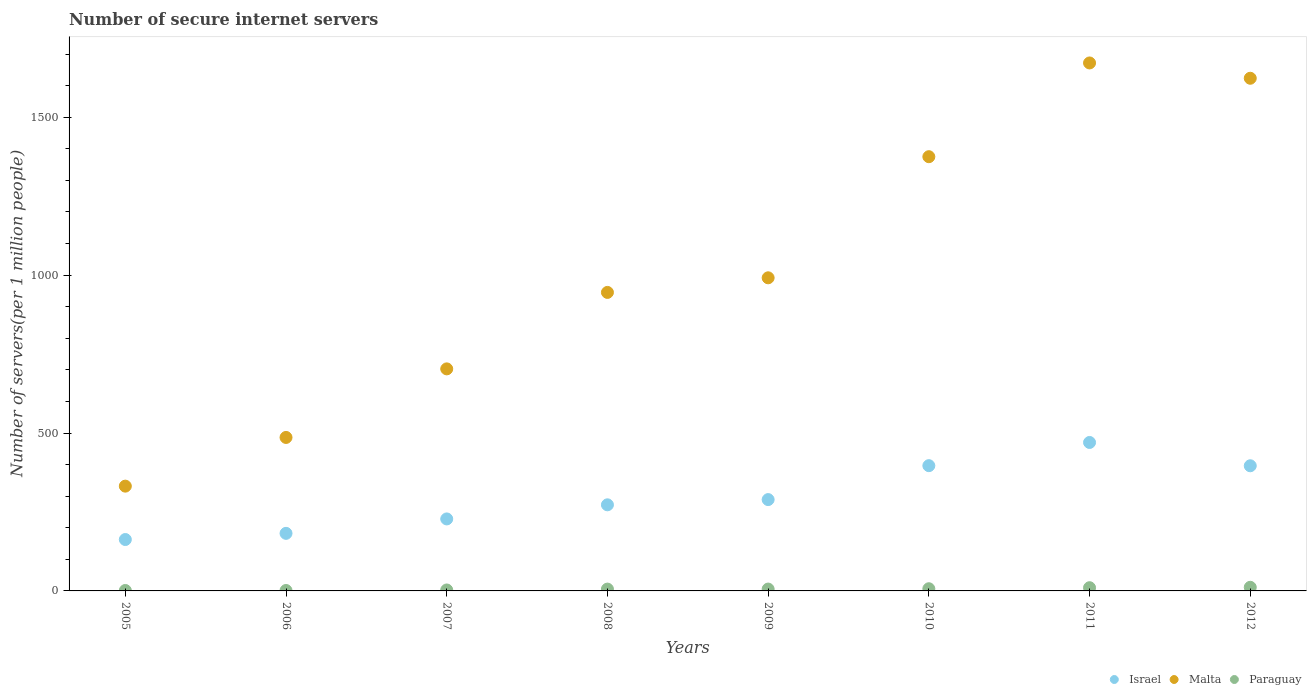What is the number of secure internet servers in Paraguay in 2006?
Your response must be concise. 1.36. Across all years, what is the maximum number of secure internet servers in Malta?
Provide a short and direct response. 1672. Across all years, what is the minimum number of secure internet servers in Malta?
Your answer should be compact. 331.82. In which year was the number of secure internet servers in Israel maximum?
Keep it short and to the point. 2011. In which year was the number of secure internet servers in Paraguay minimum?
Your answer should be compact. 2006. What is the total number of secure internet servers in Malta in the graph?
Provide a succinct answer. 8128.61. What is the difference between the number of secure internet servers in Israel in 2009 and that in 2010?
Give a very brief answer. -107.44. What is the difference between the number of secure internet servers in Paraguay in 2011 and the number of secure internet servers in Malta in 2008?
Make the answer very short. -935.17. What is the average number of secure internet servers in Paraguay per year?
Ensure brevity in your answer.  5.74. In the year 2007, what is the difference between the number of secure internet servers in Israel and number of secure internet servers in Paraguay?
Your response must be concise. 224.97. What is the ratio of the number of secure internet servers in Malta in 2010 to that in 2011?
Your response must be concise. 0.82. Is the difference between the number of secure internet servers in Israel in 2005 and 2006 greater than the difference between the number of secure internet servers in Paraguay in 2005 and 2006?
Offer a terse response. No. What is the difference between the highest and the second highest number of secure internet servers in Israel?
Ensure brevity in your answer.  73.48. What is the difference between the highest and the lowest number of secure internet servers in Paraguay?
Offer a very short reply. 10.08. Is it the case that in every year, the sum of the number of secure internet servers in Paraguay and number of secure internet servers in Israel  is greater than the number of secure internet servers in Malta?
Offer a terse response. No. Are the values on the major ticks of Y-axis written in scientific E-notation?
Provide a succinct answer. No. Does the graph contain grids?
Offer a terse response. No. Where does the legend appear in the graph?
Keep it short and to the point. Bottom right. How many legend labels are there?
Keep it short and to the point. 3. What is the title of the graph?
Your response must be concise. Number of secure internet servers. Does "East Asia (developing only)" appear as one of the legend labels in the graph?
Your answer should be compact. No. What is the label or title of the X-axis?
Make the answer very short. Years. What is the label or title of the Y-axis?
Your answer should be very brief. Number of servers(per 1 million people). What is the Number of servers(per 1 million people) in Israel in 2005?
Offer a very short reply. 162.77. What is the Number of servers(per 1 million people) in Malta in 2005?
Your answer should be very brief. 331.82. What is the Number of servers(per 1 million people) in Paraguay in 2005?
Your answer should be very brief. 1.38. What is the Number of servers(per 1 million people) of Israel in 2006?
Your answer should be very brief. 182.32. What is the Number of servers(per 1 million people) of Malta in 2006?
Ensure brevity in your answer.  486.05. What is the Number of servers(per 1 million people) of Paraguay in 2006?
Your response must be concise. 1.36. What is the Number of servers(per 1 million people) of Israel in 2007?
Your answer should be very brief. 227.99. What is the Number of servers(per 1 million people) in Malta in 2007?
Offer a very short reply. 703.18. What is the Number of servers(per 1 million people) of Paraguay in 2007?
Give a very brief answer. 3.02. What is the Number of servers(per 1 million people) of Israel in 2008?
Your answer should be very brief. 272.68. What is the Number of servers(per 1 million people) in Malta in 2008?
Give a very brief answer. 945.33. What is the Number of servers(per 1 million people) in Paraguay in 2008?
Provide a succinct answer. 5.79. What is the Number of servers(per 1 million people) in Israel in 2009?
Make the answer very short. 289.22. What is the Number of servers(per 1 million people) in Malta in 2009?
Provide a short and direct response. 991.57. What is the Number of servers(per 1 million people) of Paraguay in 2009?
Make the answer very short. 5.87. What is the Number of servers(per 1 million people) in Israel in 2010?
Provide a short and direct response. 396.66. What is the Number of servers(per 1 million people) in Malta in 2010?
Give a very brief answer. 1375.12. What is the Number of servers(per 1 million people) of Paraguay in 2010?
Provide a succinct answer. 6.92. What is the Number of servers(per 1 million people) of Israel in 2011?
Ensure brevity in your answer.  470.14. What is the Number of servers(per 1 million people) in Malta in 2011?
Provide a short and direct response. 1672. What is the Number of servers(per 1 million people) in Paraguay in 2011?
Ensure brevity in your answer.  10.17. What is the Number of servers(per 1 million people) of Israel in 2012?
Offer a very short reply. 396.31. What is the Number of servers(per 1 million people) in Malta in 2012?
Provide a succinct answer. 1623.54. What is the Number of servers(per 1 million people) of Paraguay in 2012?
Provide a short and direct response. 11.44. Across all years, what is the maximum Number of servers(per 1 million people) of Israel?
Give a very brief answer. 470.14. Across all years, what is the maximum Number of servers(per 1 million people) in Malta?
Offer a very short reply. 1672. Across all years, what is the maximum Number of servers(per 1 million people) of Paraguay?
Ensure brevity in your answer.  11.44. Across all years, what is the minimum Number of servers(per 1 million people) in Israel?
Make the answer very short. 162.77. Across all years, what is the minimum Number of servers(per 1 million people) in Malta?
Make the answer very short. 331.82. Across all years, what is the minimum Number of servers(per 1 million people) of Paraguay?
Your answer should be very brief. 1.36. What is the total Number of servers(per 1 million people) in Israel in the graph?
Ensure brevity in your answer.  2398.09. What is the total Number of servers(per 1 million people) in Malta in the graph?
Provide a succinct answer. 8128.61. What is the total Number of servers(per 1 million people) in Paraguay in the graph?
Offer a very short reply. 45.96. What is the difference between the Number of servers(per 1 million people) in Israel in 2005 and that in 2006?
Your answer should be compact. -19.55. What is the difference between the Number of servers(per 1 million people) of Malta in 2005 and that in 2006?
Give a very brief answer. -154.23. What is the difference between the Number of servers(per 1 million people) in Paraguay in 2005 and that in 2006?
Your answer should be very brief. 0.02. What is the difference between the Number of servers(per 1 million people) of Israel in 2005 and that in 2007?
Your answer should be compact. -65.22. What is the difference between the Number of servers(per 1 million people) of Malta in 2005 and that in 2007?
Provide a succinct answer. -371.36. What is the difference between the Number of servers(per 1 million people) of Paraguay in 2005 and that in 2007?
Ensure brevity in your answer.  -1.64. What is the difference between the Number of servers(per 1 million people) in Israel in 2005 and that in 2008?
Provide a succinct answer. -109.92. What is the difference between the Number of servers(per 1 million people) in Malta in 2005 and that in 2008?
Your answer should be very brief. -613.51. What is the difference between the Number of servers(per 1 million people) in Paraguay in 2005 and that in 2008?
Your answer should be very brief. -4.41. What is the difference between the Number of servers(per 1 million people) in Israel in 2005 and that in 2009?
Keep it short and to the point. -126.45. What is the difference between the Number of servers(per 1 million people) of Malta in 2005 and that in 2009?
Your answer should be very brief. -659.75. What is the difference between the Number of servers(per 1 million people) of Paraguay in 2005 and that in 2009?
Keep it short and to the point. -4.49. What is the difference between the Number of servers(per 1 million people) in Israel in 2005 and that in 2010?
Ensure brevity in your answer.  -233.89. What is the difference between the Number of servers(per 1 million people) of Malta in 2005 and that in 2010?
Your response must be concise. -1043.3. What is the difference between the Number of servers(per 1 million people) in Paraguay in 2005 and that in 2010?
Your response must be concise. -5.54. What is the difference between the Number of servers(per 1 million people) of Israel in 2005 and that in 2011?
Provide a short and direct response. -307.37. What is the difference between the Number of servers(per 1 million people) in Malta in 2005 and that in 2011?
Give a very brief answer. -1340.18. What is the difference between the Number of servers(per 1 million people) of Paraguay in 2005 and that in 2011?
Provide a succinct answer. -8.79. What is the difference between the Number of servers(per 1 million people) of Israel in 2005 and that in 2012?
Provide a short and direct response. -233.54. What is the difference between the Number of servers(per 1 million people) in Malta in 2005 and that in 2012?
Ensure brevity in your answer.  -1291.72. What is the difference between the Number of servers(per 1 million people) of Paraguay in 2005 and that in 2012?
Offer a terse response. -10.06. What is the difference between the Number of servers(per 1 million people) of Israel in 2006 and that in 2007?
Your answer should be very brief. -45.68. What is the difference between the Number of servers(per 1 million people) of Malta in 2006 and that in 2007?
Make the answer very short. -217.13. What is the difference between the Number of servers(per 1 million people) of Paraguay in 2006 and that in 2007?
Offer a terse response. -1.66. What is the difference between the Number of servers(per 1 million people) in Israel in 2006 and that in 2008?
Offer a very short reply. -90.37. What is the difference between the Number of servers(per 1 million people) of Malta in 2006 and that in 2008?
Your answer should be very brief. -459.28. What is the difference between the Number of servers(per 1 million people) in Paraguay in 2006 and that in 2008?
Make the answer very short. -4.43. What is the difference between the Number of servers(per 1 million people) in Israel in 2006 and that in 2009?
Make the answer very short. -106.91. What is the difference between the Number of servers(per 1 million people) in Malta in 2006 and that in 2009?
Make the answer very short. -505.52. What is the difference between the Number of servers(per 1 million people) in Paraguay in 2006 and that in 2009?
Give a very brief answer. -4.51. What is the difference between the Number of servers(per 1 million people) in Israel in 2006 and that in 2010?
Offer a terse response. -214.35. What is the difference between the Number of servers(per 1 million people) of Malta in 2006 and that in 2010?
Your answer should be compact. -889.07. What is the difference between the Number of servers(per 1 million people) in Paraguay in 2006 and that in 2010?
Offer a terse response. -5.56. What is the difference between the Number of servers(per 1 million people) of Israel in 2006 and that in 2011?
Make the answer very short. -287.82. What is the difference between the Number of servers(per 1 million people) of Malta in 2006 and that in 2011?
Ensure brevity in your answer.  -1185.95. What is the difference between the Number of servers(per 1 million people) in Paraguay in 2006 and that in 2011?
Make the answer very short. -8.81. What is the difference between the Number of servers(per 1 million people) in Israel in 2006 and that in 2012?
Ensure brevity in your answer.  -213.99. What is the difference between the Number of servers(per 1 million people) of Malta in 2006 and that in 2012?
Offer a very short reply. -1137.49. What is the difference between the Number of servers(per 1 million people) in Paraguay in 2006 and that in 2012?
Ensure brevity in your answer.  -10.08. What is the difference between the Number of servers(per 1 million people) of Israel in 2007 and that in 2008?
Offer a terse response. -44.69. What is the difference between the Number of servers(per 1 million people) in Malta in 2007 and that in 2008?
Keep it short and to the point. -242.15. What is the difference between the Number of servers(per 1 million people) of Paraguay in 2007 and that in 2008?
Offer a very short reply. -2.77. What is the difference between the Number of servers(per 1 million people) of Israel in 2007 and that in 2009?
Keep it short and to the point. -61.23. What is the difference between the Number of servers(per 1 million people) of Malta in 2007 and that in 2009?
Offer a very short reply. -288.39. What is the difference between the Number of servers(per 1 million people) in Paraguay in 2007 and that in 2009?
Provide a succinct answer. -2.86. What is the difference between the Number of servers(per 1 million people) in Israel in 2007 and that in 2010?
Offer a terse response. -168.67. What is the difference between the Number of servers(per 1 million people) of Malta in 2007 and that in 2010?
Offer a very short reply. -671.94. What is the difference between the Number of servers(per 1 million people) in Paraguay in 2007 and that in 2010?
Keep it short and to the point. -3.91. What is the difference between the Number of servers(per 1 million people) of Israel in 2007 and that in 2011?
Offer a very short reply. -242.15. What is the difference between the Number of servers(per 1 million people) of Malta in 2007 and that in 2011?
Your response must be concise. -968.82. What is the difference between the Number of servers(per 1 million people) of Paraguay in 2007 and that in 2011?
Offer a terse response. -7.15. What is the difference between the Number of servers(per 1 million people) in Israel in 2007 and that in 2012?
Your answer should be compact. -168.32. What is the difference between the Number of servers(per 1 million people) of Malta in 2007 and that in 2012?
Your response must be concise. -920.36. What is the difference between the Number of servers(per 1 million people) of Paraguay in 2007 and that in 2012?
Give a very brief answer. -8.43. What is the difference between the Number of servers(per 1 million people) in Israel in 2008 and that in 2009?
Your answer should be very brief. -16.54. What is the difference between the Number of servers(per 1 million people) in Malta in 2008 and that in 2009?
Provide a succinct answer. -46.24. What is the difference between the Number of servers(per 1 million people) in Paraguay in 2008 and that in 2009?
Give a very brief answer. -0.09. What is the difference between the Number of servers(per 1 million people) in Israel in 2008 and that in 2010?
Ensure brevity in your answer.  -123.98. What is the difference between the Number of servers(per 1 million people) of Malta in 2008 and that in 2010?
Keep it short and to the point. -429.79. What is the difference between the Number of servers(per 1 million people) of Paraguay in 2008 and that in 2010?
Provide a succinct answer. -1.14. What is the difference between the Number of servers(per 1 million people) of Israel in 2008 and that in 2011?
Your answer should be compact. -197.45. What is the difference between the Number of servers(per 1 million people) of Malta in 2008 and that in 2011?
Provide a succinct answer. -726.67. What is the difference between the Number of servers(per 1 million people) of Paraguay in 2008 and that in 2011?
Keep it short and to the point. -4.38. What is the difference between the Number of servers(per 1 million people) in Israel in 2008 and that in 2012?
Provide a succinct answer. -123.62. What is the difference between the Number of servers(per 1 million people) of Malta in 2008 and that in 2012?
Make the answer very short. -678.2. What is the difference between the Number of servers(per 1 million people) in Paraguay in 2008 and that in 2012?
Offer a very short reply. -5.66. What is the difference between the Number of servers(per 1 million people) in Israel in 2009 and that in 2010?
Offer a terse response. -107.44. What is the difference between the Number of servers(per 1 million people) in Malta in 2009 and that in 2010?
Offer a terse response. -383.55. What is the difference between the Number of servers(per 1 million people) in Paraguay in 2009 and that in 2010?
Offer a terse response. -1.05. What is the difference between the Number of servers(per 1 million people) in Israel in 2009 and that in 2011?
Provide a short and direct response. -180.92. What is the difference between the Number of servers(per 1 million people) in Malta in 2009 and that in 2011?
Your response must be concise. -680.43. What is the difference between the Number of servers(per 1 million people) of Paraguay in 2009 and that in 2011?
Provide a succinct answer. -4.29. What is the difference between the Number of servers(per 1 million people) in Israel in 2009 and that in 2012?
Your answer should be very brief. -107.09. What is the difference between the Number of servers(per 1 million people) in Malta in 2009 and that in 2012?
Offer a very short reply. -631.96. What is the difference between the Number of servers(per 1 million people) of Paraguay in 2009 and that in 2012?
Offer a very short reply. -5.57. What is the difference between the Number of servers(per 1 million people) in Israel in 2010 and that in 2011?
Your answer should be compact. -73.48. What is the difference between the Number of servers(per 1 million people) in Malta in 2010 and that in 2011?
Offer a terse response. -296.88. What is the difference between the Number of servers(per 1 million people) of Paraguay in 2010 and that in 2011?
Provide a succinct answer. -3.24. What is the difference between the Number of servers(per 1 million people) in Israel in 2010 and that in 2012?
Offer a terse response. 0.35. What is the difference between the Number of servers(per 1 million people) of Malta in 2010 and that in 2012?
Provide a succinct answer. -248.41. What is the difference between the Number of servers(per 1 million people) in Paraguay in 2010 and that in 2012?
Offer a terse response. -4.52. What is the difference between the Number of servers(per 1 million people) in Israel in 2011 and that in 2012?
Provide a succinct answer. 73.83. What is the difference between the Number of servers(per 1 million people) in Malta in 2011 and that in 2012?
Your response must be concise. 48.46. What is the difference between the Number of servers(per 1 million people) of Paraguay in 2011 and that in 2012?
Your answer should be compact. -1.27. What is the difference between the Number of servers(per 1 million people) of Israel in 2005 and the Number of servers(per 1 million people) of Malta in 2006?
Your response must be concise. -323.28. What is the difference between the Number of servers(per 1 million people) in Israel in 2005 and the Number of servers(per 1 million people) in Paraguay in 2006?
Provide a succinct answer. 161.41. What is the difference between the Number of servers(per 1 million people) in Malta in 2005 and the Number of servers(per 1 million people) in Paraguay in 2006?
Make the answer very short. 330.46. What is the difference between the Number of servers(per 1 million people) in Israel in 2005 and the Number of servers(per 1 million people) in Malta in 2007?
Give a very brief answer. -540.41. What is the difference between the Number of servers(per 1 million people) of Israel in 2005 and the Number of servers(per 1 million people) of Paraguay in 2007?
Your answer should be very brief. 159.75. What is the difference between the Number of servers(per 1 million people) of Malta in 2005 and the Number of servers(per 1 million people) of Paraguay in 2007?
Offer a terse response. 328.8. What is the difference between the Number of servers(per 1 million people) in Israel in 2005 and the Number of servers(per 1 million people) in Malta in 2008?
Provide a short and direct response. -782.57. What is the difference between the Number of servers(per 1 million people) of Israel in 2005 and the Number of servers(per 1 million people) of Paraguay in 2008?
Your answer should be very brief. 156.98. What is the difference between the Number of servers(per 1 million people) in Malta in 2005 and the Number of servers(per 1 million people) in Paraguay in 2008?
Your answer should be very brief. 326.03. What is the difference between the Number of servers(per 1 million people) in Israel in 2005 and the Number of servers(per 1 million people) in Malta in 2009?
Your answer should be compact. -828.8. What is the difference between the Number of servers(per 1 million people) in Israel in 2005 and the Number of servers(per 1 million people) in Paraguay in 2009?
Your response must be concise. 156.89. What is the difference between the Number of servers(per 1 million people) in Malta in 2005 and the Number of servers(per 1 million people) in Paraguay in 2009?
Ensure brevity in your answer.  325.94. What is the difference between the Number of servers(per 1 million people) in Israel in 2005 and the Number of servers(per 1 million people) in Malta in 2010?
Offer a very short reply. -1212.36. What is the difference between the Number of servers(per 1 million people) of Israel in 2005 and the Number of servers(per 1 million people) of Paraguay in 2010?
Ensure brevity in your answer.  155.84. What is the difference between the Number of servers(per 1 million people) in Malta in 2005 and the Number of servers(per 1 million people) in Paraguay in 2010?
Give a very brief answer. 324.9. What is the difference between the Number of servers(per 1 million people) of Israel in 2005 and the Number of servers(per 1 million people) of Malta in 2011?
Your response must be concise. -1509.23. What is the difference between the Number of servers(per 1 million people) in Israel in 2005 and the Number of servers(per 1 million people) in Paraguay in 2011?
Your answer should be very brief. 152.6. What is the difference between the Number of servers(per 1 million people) in Malta in 2005 and the Number of servers(per 1 million people) in Paraguay in 2011?
Your answer should be very brief. 321.65. What is the difference between the Number of servers(per 1 million people) in Israel in 2005 and the Number of servers(per 1 million people) in Malta in 2012?
Provide a succinct answer. -1460.77. What is the difference between the Number of servers(per 1 million people) in Israel in 2005 and the Number of servers(per 1 million people) in Paraguay in 2012?
Your response must be concise. 151.32. What is the difference between the Number of servers(per 1 million people) in Malta in 2005 and the Number of servers(per 1 million people) in Paraguay in 2012?
Ensure brevity in your answer.  320.38. What is the difference between the Number of servers(per 1 million people) of Israel in 2006 and the Number of servers(per 1 million people) of Malta in 2007?
Offer a terse response. -520.86. What is the difference between the Number of servers(per 1 million people) in Israel in 2006 and the Number of servers(per 1 million people) in Paraguay in 2007?
Offer a terse response. 179.3. What is the difference between the Number of servers(per 1 million people) of Malta in 2006 and the Number of servers(per 1 million people) of Paraguay in 2007?
Provide a short and direct response. 483.03. What is the difference between the Number of servers(per 1 million people) of Israel in 2006 and the Number of servers(per 1 million people) of Malta in 2008?
Offer a very short reply. -763.02. What is the difference between the Number of servers(per 1 million people) of Israel in 2006 and the Number of servers(per 1 million people) of Paraguay in 2008?
Your response must be concise. 176.53. What is the difference between the Number of servers(per 1 million people) in Malta in 2006 and the Number of servers(per 1 million people) in Paraguay in 2008?
Keep it short and to the point. 480.26. What is the difference between the Number of servers(per 1 million people) in Israel in 2006 and the Number of servers(per 1 million people) in Malta in 2009?
Your answer should be very brief. -809.25. What is the difference between the Number of servers(per 1 million people) of Israel in 2006 and the Number of servers(per 1 million people) of Paraguay in 2009?
Offer a very short reply. 176.44. What is the difference between the Number of servers(per 1 million people) in Malta in 2006 and the Number of servers(per 1 million people) in Paraguay in 2009?
Your answer should be compact. 480.18. What is the difference between the Number of servers(per 1 million people) in Israel in 2006 and the Number of servers(per 1 million people) in Malta in 2010?
Your answer should be very brief. -1192.81. What is the difference between the Number of servers(per 1 million people) in Israel in 2006 and the Number of servers(per 1 million people) in Paraguay in 2010?
Your response must be concise. 175.39. What is the difference between the Number of servers(per 1 million people) in Malta in 2006 and the Number of servers(per 1 million people) in Paraguay in 2010?
Offer a terse response. 479.13. What is the difference between the Number of servers(per 1 million people) of Israel in 2006 and the Number of servers(per 1 million people) of Malta in 2011?
Make the answer very short. -1489.68. What is the difference between the Number of servers(per 1 million people) in Israel in 2006 and the Number of servers(per 1 million people) in Paraguay in 2011?
Give a very brief answer. 172.15. What is the difference between the Number of servers(per 1 million people) of Malta in 2006 and the Number of servers(per 1 million people) of Paraguay in 2011?
Your response must be concise. 475.88. What is the difference between the Number of servers(per 1 million people) in Israel in 2006 and the Number of servers(per 1 million people) in Malta in 2012?
Provide a short and direct response. -1441.22. What is the difference between the Number of servers(per 1 million people) of Israel in 2006 and the Number of servers(per 1 million people) of Paraguay in 2012?
Offer a terse response. 170.87. What is the difference between the Number of servers(per 1 million people) in Malta in 2006 and the Number of servers(per 1 million people) in Paraguay in 2012?
Ensure brevity in your answer.  474.61. What is the difference between the Number of servers(per 1 million people) of Israel in 2007 and the Number of servers(per 1 million people) of Malta in 2008?
Your response must be concise. -717.34. What is the difference between the Number of servers(per 1 million people) of Israel in 2007 and the Number of servers(per 1 million people) of Paraguay in 2008?
Provide a succinct answer. 222.2. What is the difference between the Number of servers(per 1 million people) of Malta in 2007 and the Number of servers(per 1 million people) of Paraguay in 2008?
Your answer should be compact. 697.39. What is the difference between the Number of servers(per 1 million people) of Israel in 2007 and the Number of servers(per 1 million people) of Malta in 2009?
Your answer should be compact. -763.58. What is the difference between the Number of servers(per 1 million people) of Israel in 2007 and the Number of servers(per 1 million people) of Paraguay in 2009?
Offer a terse response. 222.12. What is the difference between the Number of servers(per 1 million people) of Malta in 2007 and the Number of servers(per 1 million people) of Paraguay in 2009?
Offer a very short reply. 697.3. What is the difference between the Number of servers(per 1 million people) in Israel in 2007 and the Number of servers(per 1 million people) in Malta in 2010?
Provide a short and direct response. -1147.13. What is the difference between the Number of servers(per 1 million people) in Israel in 2007 and the Number of servers(per 1 million people) in Paraguay in 2010?
Your answer should be compact. 221.07. What is the difference between the Number of servers(per 1 million people) of Malta in 2007 and the Number of servers(per 1 million people) of Paraguay in 2010?
Provide a short and direct response. 696.26. What is the difference between the Number of servers(per 1 million people) of Israel in 2007 and the Number of servers(per 1 million people) of Malta in 2011?
Your answer should be compact. -1444.01. What is the difference between the Number of servers(per 1 million people) of Israel in 2007 and the Number of servers(per 1 million people) of Paraguay in 2011?
Your answer should be very brief. 217.82. What is the difference between the Number of servers(per 1 million people) in Malta in 2007 and the Number of servers(per 1 million people) in Paraguay in 2011?
Provide a short and direct response. 693.01. What is the difference between the Number of servers(per 1 million people) of Israel in 2007 and the Number of servers(per 1 million people) of Malta in 2012?
Provide a short and direct response. -1395.54. What is the difference between the Number of servers(per 1 million people) of Israel in 2007 and the Number of servers(per 1 million people) of Paraguay in 2012?
Make the answer very short. 216.55. What is the difference between the Number of servers(per 1 million people) of Malta in 2007 and the Number of servers(per 1 million people) of Paraguay in 2012?
Your response must be concise. 691.74. What is the difference between the Number of servers(per 1 million people) of Israel in 2008 and the Number of servers(per 1 million people) of Malta in 2009?
Provide a succinct answer. -718.89. What is the difference between the Number of servers(per 1 million people) in Israel in 2008 and the Number of servers(per 1 million people) in Paraguay in 2009?
Provide a short and direct response. 266.81. What is the difference between the Number of servers(per 1 million people) in Malta in 2008 and the Number of servers(per 1 million people) in Paraguay in 2009?
Your answer should be compact. 939.46. What is the difference between the Number of servers(per 1 million people) of Israel in 2008 and the Number of servers(per 1 million people) of Malta in 2010?
Your answer should be very brief. -1102.44. What is the difference between the Number of servers(per 1 million people) in Israel in 2008 and the Number of servers(per 1 million people) in Paraguay in 2010?
Provide a short and direct response. 265.76. What is the difference between the Number of servers(per 1 million people) of Malta in 2008 and the Number of servers(per 1 million people) of Paraguay in 2010?
Offer a very short reply. 938.41. What is the difference between the Number of servers(per 1 million people) in Israel in 2008 and the Number of servers(per 1 million people) in Malta in 2011?
Provide a short and direct response. -1399.31. What is the difference between the Number of servers(per 1 million people) of Israel in 2008 and the Number of servers(per 1 million people) of Paraguay in 2011?
Provide a succinct answer. 262.52. What is the difference between the Number of servers(per 1 million people) in Malta in 2008 and the Number of servers(per 1 million people) in Paraguay in 2011?
Provide a short and direct response. 935.17. What is the difference between the Number of servers(per 1 million people) of Israel in 2008 and the Number of servers(per 1 million people) of Malta in 2012?
Provide a short and direct response. -1350.85. What is the difference between the Number of servers(per 1 million people) of Israel in 2008 and the Number of servers(per 1 million people) of Paraguay in 2012?
Offer a terse response. 261.24. What is the difference between the Number of servers(per 1 million people) of Malta in 2008 and the Number of servers(per 1 million people) of Paraguay in 2012?
Provide a short and direct response. 933.89. What is the difference between the Number of servers(per 1 million people) in Israel in 2009 and the Number of servers(per 1 million people) in Malta in 2010?
Ensure brevity in your answer.  -1085.9. What is the difference between the Number of servers(per 1 million people) in Israel in 2009 and the Number of servers(per 1 million people) in Paraguay in 2010?
Make the answer very short. 282.3. What is the difference between the Number of servers(per 1 million people) in Malta in 2009 and the Number of servers(per 1 million people) in Paraguay in 2010?
Provide a succinct answer. 984.65. What is the difference between the Number of servers(per 1 million people) of Israel in 2009 and the Number of servers(per 1 million people) of Malta in 2011?
Ensure brevity in your answer.  -1382.78. What is the difference between the Number of servers(per 1 million people) in Israel in 2009 and the Number of servers(per 1 million people) in Paraguay in 2011?
Make the answer very short. 279.05. What is the difference between the Number of servers(per 1 million people) in Malta in 2009 and the Number of servers(per 1 million people) in Paraguay in 2011?
Ensure brevity in your answer.  981.4. What is the difference between the Number of servers(per 1 million people) in Israel in 2009 and the Number of servers(per 1 million people) in Malta in 2012?
Ensure brevity in your answer.  -1334.31. What is the difference between the Number of servers(per 1 million people) in Israel in 2009 and the Number of servers(per 1 million people) in Paraguay in 2012?
Provide a succinct answer. 277.78. What is the difference between the Number of servers(per 1 million people) in Malta in 2009 and the Number of servers(per 1 million people) in Paraguay in 2012?
Keep it short and to the point. 980.13. What is the difference between the Number of servers(per 1 million people) in Israel in 2010 and the Number of servers(per 1 million people) in Malta in 2011?
Your response must be concise. -1275.34. What is the difference between the Number of servers(per 1 million people) in Israel in 2010 and the Number of servers(per 1 million people) in Paraguay in 2011?
Offer a terse response. 386.49. What is the difference between the Number of servers(per 1 million people) of Malta in 2010 and the Number of servers(per 1 million people) of Paraguay in 2011?
Make the answer very short. 1364.96. What is the difference between the Number of servers(per 1 million people) in Israel in 2010 and the Number of servers(per 1 million people) in Malta in 2012?
Your response must be concise. -1226.87. What is the difference between the Number of servers(per 1 million people) of Israel in 2010 and the Number of servers(per 1 million people) of Paraguay in 2012?
Your answer should be compact. 385.22. What is the difference between the Number of servers(per 1 million people) of Malta in 2010 and the Number of servers(per 1 million people) of Paraguay in 2012?
Offer a terse response. 1363.68. What is the difference between the Number of servers(per 1 million people) of Israel in 2011 and the Number of servers(per 1 million people) of Malta in 2012?
Keep it short and to the point. -1153.4. What is the difference between the Number of servers(per 1 million people) in Israel in 2011 and the Number of servers(per 1 million people) in Paraguay in 2012?
Offer a very short reply. 458.69. What is the difference between the Number of servers(per 1 million people) of Malta in 2011 and the Number of servers(per 1 million people) of Paraguay in 2012?
Provide a short and direct response. 1660.56. What is the average Number of servers(per 1 million people) of Israel per year?
Offer a terse response. 299.76. What is the average Number of servers(per 1 million people) of Malta per year?
Provide a short and direct response. 1016.08. What is the average Number of servers(per 1 million people) of Paraguay per year?
Offer a terse response. 5.74. In the year 2005, what is the difference between the Number of servers(per 1 million people) of Israel and Number of servers(per 1 million people) of Malta?
Offer a terse response. -169.05. In the year 2005, what is the difference between the Number of servers(per 1 million people) in Israel and Number of servers(per 1 million people) in Paraguay?
Your answer should be very brief. 161.39. In the year 2005, what is the difference between the Number of servers(per 1 million people) of Malta and Number of servers(per 1 million people) of Paraguay?
Make the answer very short. 330.44. In the year 2006, what is the difference between the Number of servers(per 1 million people) in Israel and Number of servers(per 1 million people) in Malta?
Offer a terse response. -303.73. In the year 2006, what is the difference between the Number of servers(per 1 million people) of Israel and Number of servers(per 1 million people) of Paraguay?
Make the answer very short. 180.96. In the year 2006, what is the difference between the Number of servers(per 1 million people) in Malta and Number of servers(per 1 million people) in Paraguay?
Make the answer very short. 484.69. In the year 2007, what is the difference between the Number of servers(per 1 million people) of Israel and Number of servers(per 1 million people) of Malta?
Your answer should be compact. -475.19. In the year 2007, what is the difference between the Number of servers(per 1 million people) of Israel and Number of servers(per 1 million people) of Paraguay?
Make the answer very short. 224.97. In the year 2007, what is the difference between the Number of servers(per 1 million people) of Malta and Number of servers(per 1 million people) of Paraguay?
Your response must be concise. 700.16. In the year 2008, what is the difference between the Number of servers(per 1 million people) of Israel and Number of servers(per 1 million people) of Malta?
Keep it short and to the point. -672.65. In the year 2008, what is the difference between the Number of servers(per 1 million people) in Israel and Number of servers(per 1 million people) in Paraguay?
Provide a short and direct response. 266.9. In the year 2008, what is the difference between the Number of servers(per 1 million people) of Malta and Number of servers(per 1 million people) of Paraguay?
Provide a short and direct response. 939.55. In the year 2009, what is the difference between the Number of servers(per 1 million people) in Israel and Number of servers(per 1 million people) in Malta?
Offer a terse response. -702.35. In the year 2009, what is the difference between the Number of servers(per 1 million people) in Israel and Number of servers(per 1 million people) in Paraguay?
Provide a short and direct response. 283.35. In the year 2009, what is the difference between the Number of servers(per 1 million people) in Malta and Number of servers(per 1 million people) in Paraguay?
Provide a short and direct response. 985.7. In the year 2010, what is the difference between the Number of servers(per 1 million people) of Israel and Number of servers(per 1 million people) of Malta?
Provide a short and direct response. -978.46. In the year 2010, what is the difference between the Number of servers(per 1 million people) of Israel and Number of servers(per 1 million people) of Paraguay?
Give a very brief answer. 389.74. In the year 2010, what is the difference between the Number of servers(per 1 million people) of Malta and Number of servers(per 1 million people) of Paraguay?
Provide a succinct answer. 1368.2. In the year 2011, what is the difference between the Number of servers(per 1 million people) in Israel and Number of servers(per 1 million people) in Malta?
Provide a short and direct response. -1201.86. In the year 2011, what is the difference between the Number of servers(per 1 million people) in Israel and Number of servers(per 1 million people) in Paraguay?
Your response must be concise. 459.97. In the year 2011, what is the difference between the Number of servers(per 1 million people) of Malta and Number of servers(per 1 million people) of Paraguay?
Give a very brief answer. 1661.83. In the year 2012, what is the difference between the Number of servers(per 1 million people) in Israel and Number of servers(per 1 million people) in Malta?
Your answer should be compact. -1227.23. In the year 2012, what is the difference between the Number of servers(per 1 million people) in Israel and Number of servers(per 1 million people) in Paraguay?
Offer a terse response. 384.87. In the year 2012, what is the difference between the Number of servers(per 1 million people) in Malta and Number of servers(per 1 million people) in Paraguay?
Your answer should be very brief. 1612.09. What is the ratio of the Number of servers(per 1 million people) in Israel in 2005 to that in 2006?
Provide a succinct answer. 0.89. What is the ratio of the Number of servers(per 1 million people) in Malta in 2005 to that in 2006?
Your answer should be compact. 0.68. What is the ratio of the Number of servers(per 1 million people) of Paraguay in 2005 to that in 2006?
Make the answer very short. 1.02. What is the ratio of the Number of servers(per 1 million people) in Israel in 2005 to that in 2007?
Give a very brief answer. 0.71. What is the ratio of the Number of servers(per 1 million people) in Malta in 2005 to that in 2007?
Provide a succinct answer. 0.47. What is the ratio of the Number of servers(per 1 million people) of Paraguay in 2005 to that in 2007?
Make the answer very short. 0.46. What is the ratio of the Number of servers(per 1 million people) in Israel in 2005 to that in 2008?
Provide a succinct answer. 0.6. What is the ratio of the Number of servers(per 1 million people) of Malta in 2005 to that in 2008?
Keep it short and to the point. 0.35. What is the ratio of the Number of servers(per 1 million people) of Paraguay in 2005 to that in 2008?
Make the answer very short. 0.24. What is the ratio of the Number of servers(per 1 million people) of Israel in 2005 to that in 2009?
Give a very brief answer. 0.56. What is the ratio of the Number of servers(per 1 million people) in Malta in 2005 to that in 2009?
Provide a succinct answer. 0.33. What is the ratio of the Number of servers(per 1 million people) of Paraguay in 2005 to that in 2009?
Offer a terse response. 0.23. What is the ratio of the Number of servers(per 1 million people) in Israel in 2005 to that in 2010?
Offer a very short reply. 0.41. What is the ratio of the Number of servers(per 1 million people) in Malta in 2005 to that in 2010?
Your answer should be very brief. 0.24. What is the ratio of the Number of servers(per 1 million people) in Paraguay in 2005 to that in 2010?
Give a very brief answer. 0.2. What is the ratio of the Number of servers(per 1 million people) of Israel in 2005 to that in 2011?
Your answer should be very brief. 0.35. What is the ratio of the Number of servers(per 1 million people) in Malta in 2005 to that in 2011?
Give a very brief answer. 0.2. What is the ratio of the Number of servers(per 1 million people) in Paraguay in 2005 to that in 2011?
Make the answer very short. 0.14. What is the ratio of the Number of servers(per 1 million people) of Israel in 2005 to that in 2012?
Give a very brief answer. 0.41. What is the ratio of the Number of servers(per 1 million people) of Malta in 2005 to that in 2012?
Your answer should be compact. 0.2. What is the ratio of the Number of servers(per 1 million people) of Paraguay in 2005 to that in 2012?
Give a very brief answer. 0.12. What is the ratio of the Number of servers(per 1 million people) in Israel in 2006 to that in 2007?
Your answer should be very brief. 0.8. What is the ratio of the Number of servers(per 1 million people) in Malta in 2006 to that in 2007?
Offer a very short reply. 0.69. What is the ratio of the Number of servers(per 1 million people) of Paraguay in 2006 to that in 2007?
Offer a very short reply. 0.45. What is the ratio of the Number of servers(per 1 million people) in Israel in 2006 to that in 2008?
Your answer should be very brief. 0.67. What is the ratio of the Number of servers(per 1 million people) of Malta in 2006 to that in 2008?
Offer a terse response. 0.51. What is the ratio of the Number of servers(per 1 million people) in Paraguay in 2006 to that in 2008?
Give a very brief answer. 0.23. What is the ratio of the Number of servers(per 1 million people) in Israel in 2006 to that in 2009?
Offer a very short reply. 0.63. What is the ratio of the Number of servers(per 1 million people) in Malta in 2006 to that in 2009?
Give a very brief answer. 0.49. What is the ratio of the Number of servers(per 1 million people) of Paraguay in 2006 to that in 2009?
Give a very brief answer. 0.23. What is the ratio of the Number of servers(per 1 million people) of Israel in 2006 to that in 2010?
Your answer should be very brief. 0.46. What is the ratio of the Number of servers(per 1 million people) in Malta in 2006 to that in 2010?
Offer a very short reply. 0.35. What is the ratio of the Number of servers(per 1 million people) in Paraguay in 2006 to that in 2010?
Your answer should be very brief. 0.2. What is the ratio of the Number of servers(per 1 million people) of Israel in 2006 to that in 2011?
Give a very brief answer. 0.39. What is the ratio of the Number of servers(per 1 million people) of Malta in 2006 to that in 2011?
Your response must be concise. 0.29. What is the ratio of the Number of servers(per 1 million people) of Paraguay in 2006 to that in 2011?
Keep it short and to the point. 0.13. What is the ratio of the Number of servers(per 1 million people) in Israel in 2006 to that in 2012?
Your answer should be compact. 0.46. What is the ratio of the Number of servers(per 1 million people) of Malta in 2006 to that in 2012?
Your answer should be very brief. 0.3. What is the ratio of the Number of servers(per 1 million people) in Paraguay in 2006 to that in 2012?
Offer a very short reply. 0.12. What is the ratio of the Number of servers(per 1 million people) of Israel in 2007 to that in 2008?
Your answer should be compact. 0.84. What is the ratio of the Number of servers(per 1 million people) of Malta in 2007 to that in 2008?
Your response must be concise. 0.74. What is the ratio of the Number of servers(per 1 million people) of Paraguay in 2007 to that in 2008?
Provide a succinct answer. 0.52. What is the ratio of the Number of servers(per 1 million people) in Israel in 2007 to that in 2009?
Make the answer very short. 0.79. What is the ratio of the Number of servers(per 1 million people) in Malta in 2007 to that in 2009?
Your response must be concise. 0.71. What is the ratio of the Number of servers(per 1 million people) of Paraguay in 2007 to that in 2009?
Your answer should be very brief. 0.51. What is the ratio of the Number of servers(per 1 million people) of Israel in 2007 to that in 2010?
Make the answer very short. 0.57. What is the ratio of the Number of servers(per 1 million people) in Malta in 2007 to that in 2010?
Ensure brevity in your answer.  0.51. What is the ratio of the Number of servers(per 1 million people) of Paraguay in 2007 to that in 2010?
Your answer should be compact. 0.44. What is the ratio of the Number of servers(per 1 million people) of Israel in 2007 to that in 2011?
Your answer should be compact. 0.48. What is the ratio of the Number of servers(per 1 million people) of Malta in 2007 to that in 2011?
Ensure brevity in your answer.  0.42. What is the ratio of the Number of servers(per 1 million people) of Paraguay in 2007 to that in 2011?
Your answer should be very brief. 0.3. What is the ratio of the Number of servers(per 1 million people) of Israel in 2007 to that in 2012?
Make the answer very short. 0.58. What is the ratio of the Number of servers(per 1 million people) of Malta in 2007 to that in 2012?
Your response must be concise. 0.43. What is the ratio of the Number of servers(per 1 million people) of Paraguay in 2007 to that in 2012?
Provide a succinct answer. 0.26. What is the ratio of the Number of servers(per 1 million people) of Israel in 2008 to that in 2009?
Ensure brevity in your answer.  0.94. What is the ratio of the Number of servers(per 1 million people) in Malta in 2008 to that in 2009?
Offer a very short reply. 0.95. What is the ratio of the Number of servers(per 1 million people) in Paraguay in 2008 to that in 2009?
Offer a terse response. 0.99. What is the ratio of the Number of servers(per 1 million people) of Israel in 2008 to that in 2010?
Provide a short and direct response. 0.69. What is the ratio of the Number of servers(per 1 million people) in Malta in 2008 to that in 2010?
Make the answer very short. 0.69. What is the ratio of the Number of servers(per 1 million people) of Paraguay in 2008 to that in 2010?
Your answer should be compact. 0.84. What is the ratio of the Number of servers(per 1 million people) of Israel in 2008 to that in 2011?
Offer a terse response. 0.58. What is the ratio of the Number of servers(per 1 million people) of Malta in 2008 to that in 2011?
Your answer should be very brief. 0.57. What is the ratio of the Number of servers(per 1 million people) of Paraguay in 2008 to that in 2011?
Offer a very short reply. 0.57. What is the ratio of the Number of servers(per 1 million people) of Israel in 2008 to that in 2012?
Give a very brief answer. 0.69. What is the ratio of the Number of servers(per 1 million people) in Malta in 2008 to that in 2012?
Your answer should be compact. 0.58. What is the ratio of the Number of servers(per 1 million people) of Paraguay in 2008 to that in 2012?
Ensure brevity in your answer.  0.51. What is the ratio of the Number of servers(per 1 million people) of Israel in 2009 to that in 2010?
Make the answer very short. 0.73. What is the ratio of the Number of servers(per 1 million people) in Malta in 2009 to that in 2010?
Keep it short and to the point. 0.72. What is the ratio of the Number of servers(per 1 million people) in Paraguay in 2009 to that in 2010?
Provide a short and direct response. 0.85. What is the ratio of the Number of servers(per 1 million people) in Israel in 2009 to that in 2011?
Give a very brief answer. 0.62. What is the ratio of the Number of servers(per 1 million people) in Malta in 2009 to that in 2011?
Make the answer very short. 0.59. What is the ratio of the Number of servers(per 1 million people) of Paraguay in 2009 to that in 2011?
Make the answer very short. 0.58. What is the ratio of the Number of servers(per 1 million people) of Israel in 2009 to that in 2012?
Provide a short and direct response. 0.73. What is the ratio of the Number of servers(per 1 million people) of Malta in 2009 to that in 2012?
Your response must be concise. 0.61. What is the ratio of the Number of servers(per 1 million people) in Paraguay in 2009 to that in 2012?
Offer a terse response. 0.51. What is the ratio of the Number of servers(per 1 million people) in Israel in 2010 to that in 2011?
Ensure brevity in your answer.  0.84. What is the ratio of the Number of servers(per 1 million people) in Malta in 2010 to that in 2011?
Your answer should be very brief. 0.82. What is the ratio of the Number of servers(per 1 million people) in Paraguay in 2010 to that in 2011?
Provide a short and direct response. 0.68. What is the ratio of the Number of servers(per 1 million people) of Israel in 2010 to that in 2012?
Provide a succinct answer. 1. What is the ratio of the Number of servers(per 1 million people) in Malta in 2010 to that in 2012?
Offer a very short reply. 0.85. What is the ratio of the Number of servers(per 1 million people) of Paraguay in 2010 to that in 2012?
Your answer should be very brief. 0.61. What is the ratio of the Number of servers(per 1 million people) in Israel in 2011 to that in 2012?
Provide a succinct answer. 1.19. What is the ratio of the Number of servers(per 1 million people) in Malta in 2011 to that in 2012?
Your answer should be very brief. 1.03. What is the ratio of the Number of servers(per 1 million people) in Paraguay in 2011 to that in 2012?
Provide a short and direct response. 0.89. What is the difference between the highest and the second highest Number of servers(per 1 million people) in Israel?
Your response must be concise. 73.48. What is the difference between the highest and the second highest Number of servers(per 1 million people) in Malta?
Your answer should be compact. 48.46. What is the difference between the highest and the second highest Number of servers(per 1 million people) of Paraguay?
Ensure brevity in your answer.  1.27. What is the difference between the highest and the lowest Number of servers(per 1 million people) of Israel?
Your answer should be very brief. 307.37. What is the difference between the highest and the lowest Number of servers(per 1 million people) in Malta?
Your answer should be compact. 1340.18. What is the difference between the highest and the lowest Number of servers(per 1 million people) of Paraguay?
Keep it short and to the point. 10.08. 